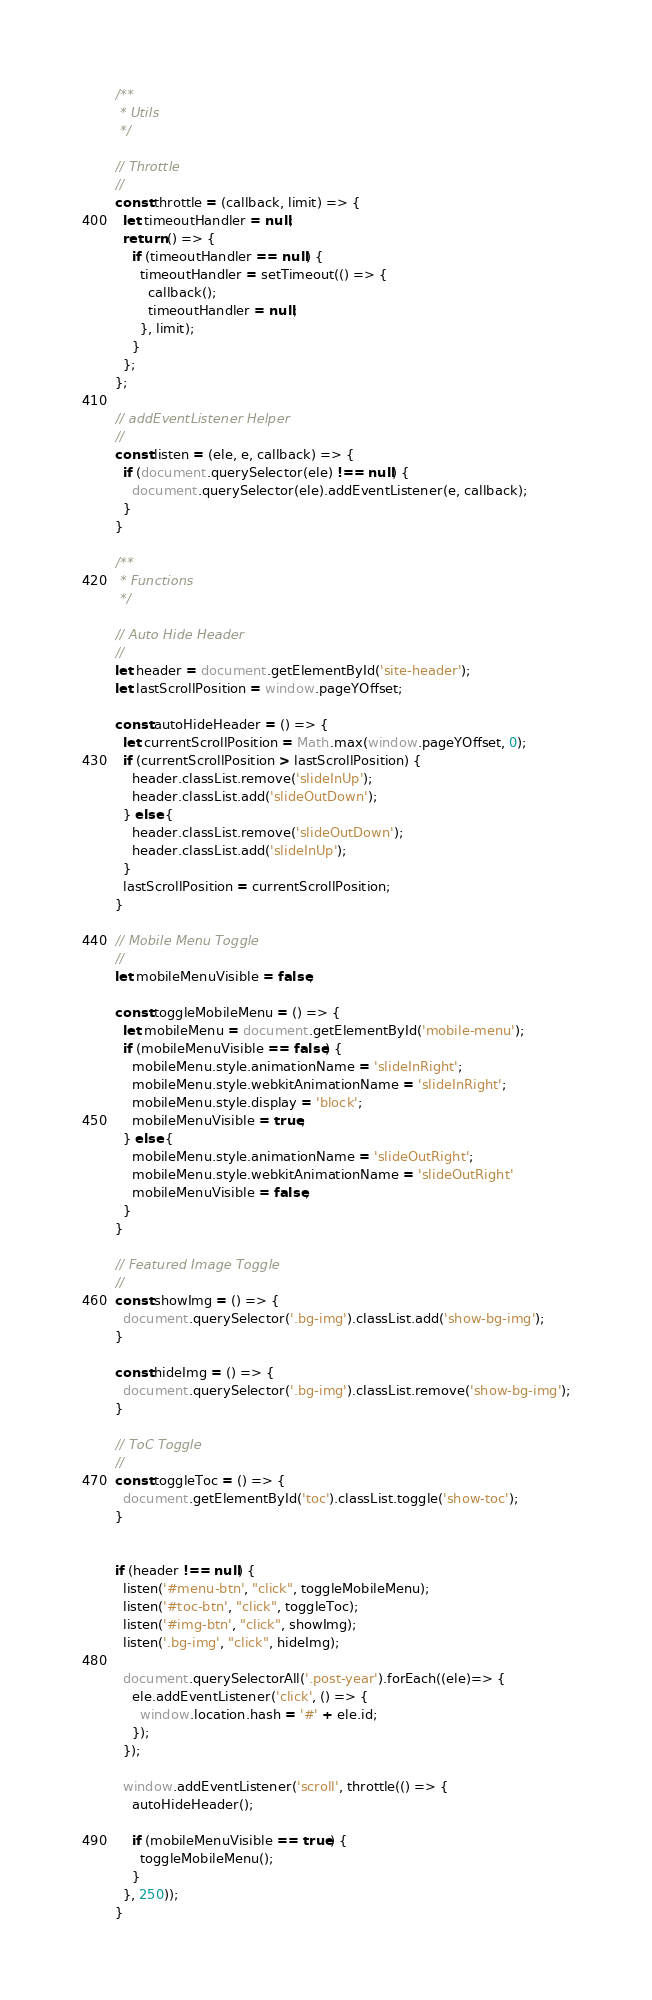<code> <loc_0><loc_0><loc_500><loc_500><_JavaScript_>/**
 * Utils
 */

// Throttle
//
const throttle = (callback, limit) => {
  let timeoutHandler = null;
  return () => {
    if (timeoutHandler == null) {
      timeoutHandler = setTimeout(() => {
        callback();
        timeoutHandler = null;
      }, limit);
    }
  };
};

// addEventListener Helper
//
const listen = (ele, e, callback) => {
  if (document.querySelector(ele) !== null) {
    document.querySelector(ele).addEventListener(e, callback);
  }
}

/**
 * Functions
 */

// Auto Hide Header
//
let header = document.getElementById('site-header');
let lastScrollPosition = window.pageYOffset;

const autoHideHeader = () => {
  let currentScrollPosition = Math.max(window.pageYOffset, 0);
  if (currentScrollPosition > lastScrollPosition) {
    header.classList.remove('slideInUp');
    header.classList.add('slideOutDown');
  } else {
    header.classList.remove('slideOutDown');
    header.classList.add('slideInUp');
  }
  lastScrollPosition = currentScrollPosition;
}

// Mobile Menu Toggle
//
let mobileMenuVisible = false;

const toggleMobileMenu = () => {
  let mobileMenu = document.getElementById('mobile-menu');
  if (mobileMenuVisible == false) {
    mobileMenu.style.animationName = 'slideInRight';
    mobileMenu.style.webkitAnimationName = 'slideInRight';
    mobileMenu.style.display = 'block';
    mobileMenuVisible = true;
  } else {
    mobileMenu.style.animationName = 'slideOutRight';
    mobileMenu.style.webkitAnimationName = 'slideOutRight'
    mobileMenuVisible = false;
  }
}

// Featured Image Toggle
//
const showImg = () => {
  document.querySelector('.bg-img').classList.add('show-bg-img');
}

const hideImg = () => {
  document.querySelector('.bg-img').classList.remove('show-bg-img');
}

// ToC Toggle
//
const toggleToc = () => {
  document.getElementById('toc').classList.toggle('show-toc');
}


if (header !== null) {
  listen('#menu-btn', "click", toggleMobileMenu);
  listen('#toc-btn', "click", toggleToc);
  listen('#img-btn', "click", showImg);
  listen('.bg-img', "click", hideImg);

  document.querySelectorAll('.post-year').forEach((ele)=> {
    ele.addEventListener('click', () => {
      window.location.hash = '#' + ele.id;
    });
  });

  window.addEventListener('scroll', throttle(() => {
    autoHideHeader();

    if (mobileMenuVisible == true) {
      toggleMobileMenu();
    }
  }, 250));
}
</code> 